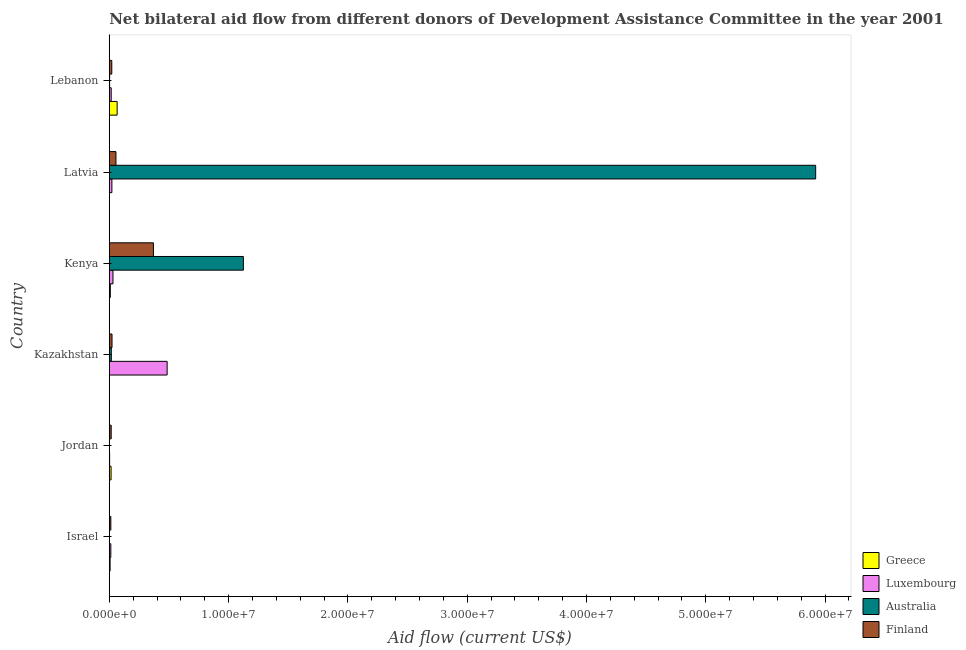Are the number of bars per tick equal to the number of legend labels?
Ensure brevity in your answer.  Yes. What is the label of the 4th group of bars from the top?
Offer a very short reply. Kazakhstan. In how many cases, is the number of bars for a given country not equal to the number of legend labels?
Ensure brevity in your answer.  0. What is the amount of aid given by australia in Kazakhstan?
Provide a succinct answer. 1.70e+05. Across all countries, what is the maximum amount of aid given by australia?
Keep it short and to the point. 5.92e+07. Across all countries, what is the minimum amount of aid given by luxembourg?
Offer a terse response. 3.00e+04. In which country was the amount of aid given by greece maximum?
Ensure brevity in your answer.  Lebanon. In which country was the amount of aid given by greece minimum?
Your answer should be compact. Kazakhstan. What is the total amount of aid given by finland in the graph?
Provide a succinct answer. 4.99e+06. What is the difference between the amount of aid given by greece in Israel and that in Lebanon?
Give a very brief answer. -5.90e+05. What is the difference between the amount of aid given by finland in Latvia and the amount of aid given by australia in Israel?
Keep it short and to the point. 5.50e+05. What is the average amount of aid given by finland per country?
Provide a succinct answer. 8.32e+05. What is the difference between the amount of aid given by luxembourg and amount of aid given by australia in Kenya?
Provide a succinct answer. -1.09e+07. In how many countries, is the amount of aid given by luxembourg greater than 36000000 US$?
Make the answer very short. 0. What is the ratio of the amount of aid given by greece in Kenya to that in Lebanon?
Provide a succinct answer. 0.14. Is the amount of aid given by finland in Jordan less than that in Kazakhstan?
Ensure brevity in your answer.  Yes. Is the difference between the amount of aid given by greece in Jordan and Kazakhstan greater than the difference between the amount of aid given by luxembourg in Jordan and Kazakhstan?
Keep it short and to the point. Yes. What is the difference between the highest and the second highest amount of aid given by greece?
Your answer should be compact. 5.10e+05. What is the difference between the highest and the lowest amount of aid given by australia?
Keep it short and to the point. 5.92e+07. In how many countries, is the amount of aid given by greece greater than the average amount of aid given by greece taken over all countries?
Provide a short and direct response. 1. Is it the case that in every country, the sum of the amount of aid given by luxembourg and amount of aid given by finland is greater than the sum of amount of aid given by greece and amount of aid given by australia?
Keep it short and to the point. No. What does the 2nd bar from the top in Israel represents?
Make the answer very short. Australia. What does the 4th bar from the bottom in Kenya represents?
Offer a terse response. Finland. Is it the case that in every country, the sum of the amount of aid given by greece and amount of aid given by luxembourg is greater than the amount of aid given by australia?
Offer a terse response. No. How many bars are there?
Offer a terse response. 24. Are all the bars in the graph horizontal?
Provide a succinct answer. Yes. How many countries are there in the graph?
Ensure brevity in your answer.  6. What is the difference between two consecutive major ticks on the X-axis?
Your answer should be compact. 1.00e+07. Are the values on the major ticks of X-axis written in scientific E-notation?
Provide a succinct answer. Yes. Does the graph contain grids?
Keep it short and to the point. No. Where does the legend appear in the graph?
Provide a short and direct response. Bottom right. How are the legend labels stacked?
Offer a terse response. Vertical. What is the title of the graph?
Provide a succinct answer. Net bilateral aid flow from different donors of Development Assistance Committee in the year 2001. Does "Agricultural land" appear as one of the legend labels in the graph?
Your answer should be very brief. No. What is the label or title of the Y-axis?
Your answer should be very brief. Country. What is the Aid flow (current US$) in Finland in Israel?
Your answer should be very brief. 1.30e+05. What is the Aid flow (current US$) of Greece in Jordan?
Keep it short and to the point. 1.50e+05. What is the Aid flow (current US$) of Luxembourg in Kazakhstan?
Your answer should be compact. 4.85e+06. What is the Aid flow (current US$) of Finland in Kazakhstan?
Give a very brief answer. 2.30e+05. What is the Aid flow (current US$) of Greece in Kenya?
Your answer should be compact. 9.00e+04. What is the Aid flow (current US$) in Australia in Kenya?
Keep it short and to the point. 1.12e+07. What is the Aid flow (current US$) of Finland in Kenya?
Offer a very short reply. 3.70e+06. What is the Aid flow (current US$) in Greece in Latvia?
Provide a short and direct response. 2.00e+04. What is the Aid flow (current US$) in Luxembourg in Latvia?
Offer a terse response. 2.20e+05. What is the Aid flow (current US$) in Australia in Latvia?
Offer a terse response. 5.92e+07. What is the Aid flow (current US$) in Finland in Latvia?
Offer a terse response. 5.60e+05. What is the Aid flow (current US$) in Greece in Lebanon?
Provide a succinct answer. 6.60e+05. What is the Aid flow (current US$) in Luxembourg in Lebanon?
Keep it short and to the point. 1.60e+05. Across all countries, what is the maximum Aid flow (current US$) in Luxembourg?
Provide a short and direct response. 4.85e+06. Across all countries, what is the maximum Aid flow (current US$) of Australia?
Keep it short and to the point. 5.92e+07. Across all countries, what is the maximum Aid flow (current US$) of Finland?
Your response must be concise. 3.70e+06. Across all countries, what is the minimum Aid flow (current US$) of Finland?
Ensure brevity in your answer.  1.30e+05. What is the total Aid flow (current US$) of Greece in the graph?
Make the answer very short. 1.00e+06. What is the total Aid flow (current US$) in Luxembourg in the graph?
Provide a succinct answer. 5.70e+06. What is the total Aid flow (current US$) of Australia in the graph?
Keep it short and to the point. 7.07e+07. What is the total Aid flow (current US$) in Finland in the graph?
Provide a short and direct response. 4.99e+06. What is the difference between the Aid flow (current US$) in Greece in Israel and that in Jordan?
Make the answer very short. -8.00e+04. What is the difference between the Aid flow (current US$) of Luxembourg in Israel and that in Jordan?
Offer a terse response. 1.00e+05. What is the difference between the Aid flow (current US$) in Greece in Israel and that in Kazakhstan?
Offer a very short reply. 6.00e+04. What is the difference between the Aid flow (current US$) in Luxembourg in Israel and that in Kazakhstan?
Give a very brief answer. -4.72e+06. What is the difference between the Aid flow (current US$) of Australia in Israel and that in Kazakhstan?
Your response must be concise. -1.60e+05. What is the difference between the Aid flow (current US$) of Finland in Israel and that in Kazakhstan?
Make the answer very short. -1.00e+05. What is the difference between the Aid flow (current US$) of Luxembourg in Israel and that in Kenya?
Give a very brief answer. -1.80e+05. What is the difference between the Aid flow (current US$) in Australia in Israel and that in Kenya?
Provide a short and direct response. -1.12e+07. What is the difference between the Aid flow (current US$) in Finland in Israel and that in Kenya?
Your response must be concise. -3.57e+06. What is the difference between the Aid flow (current US$) in Luxembourg in Israel and that in Latvia?
Your answer should be compact. -9.00e+04. What is the difference between the Aid flow (current US$) of Australia in Israel and that in Latvia?
Your answer should be compact. -5.92e+07. What is the difference between the Aid flow (current US$) in Finland in Israel and that in Latvia?
Provide a succinct answer. -4.30e+05. What is the difference between the Aid flow (current US$) of Greece in Israel and that in Lebanon?
Provide a succinct answer. -5.90e+05. What is the difference between the Aid flow (current US$) of Luxembourg in Israel and that in Lebanon?
Provide a short and direct response. -3.00e+04. What is the difference between the Aid flow (current US$) in Luxembourg in Jordan and that in Kazakhstan?
Give a very brief answer. -4.82e+06. What is the difference between the Aid flow (current US$) in Australia in Jordan and that in Kazakhstan?
Provide a succinct answer. -1.60e+05. What is the difference between the Aid flow (current US$) in Greece in Jordan and that in Kenya?
Provide a succinct answer. 6.00e+04. What is the difference between the Aid flow (current US$) of Luxembourg in Jordan and that in Kenya?
Provide a succinct answer. -2.80e+05. What is the difference between the Aid flow (current US$) in Australia in Jordan and that in Kenya?
Provide a short and direct response. -1.12e+07. What is the difference between the Aid flow (current US$) in Finland in Jordan and that in Kenya?
Make the answer very short. -3.54e+06. What is the difference between the Aid flow (current US$) in Luxembourg in Jordan and that in Latvia?
Keep it short and to the point. -1.90e+05. What is the difference between the Aid flow (current US$) in Australia in Jordan and that in Latvia?
Your answer should be compact. -5.92e+07. What is the difference between the Aid flow (current US$) in Finland in Jordan and that in Latvia?
Give a very brief answer. -4.00e+05. What is the difference between the Aid flow (current US$) in Greece in Jordan and that in Lebanon?
Ensure brevity in your answer.  -5.10e+05. What is the difference between the Aid flow (current US$) of Greece in Kazakhstan and that in Kenya?
Give a very brief answer. -8.00e+04. What is the difference between the Aid flow (current US$) of Luxembourg in Kazakhstan and that in Kenya?
Offer a very short reply. 4.54e+06. What is the difference between the Aid flow (current US$) of Australia in Kazakhstan and that in Kenya?
Keep it short and to the point. -1.11e+07. What is the difference between the Aid flow (current US$) in Finland in Kazakhstan and that in Kenya?
Make the answer very short. -3.47e+06. What is the difference between the Aid flow (current US$) in Luxembourg in Kazakhstan and that in Latvia?
Provide a short and direct response. 4.63e+06. What is the difference between the Aid flow (current US$) of Australia in Kazakhstan and that in Latvia?
Give a very brief answer. -5.90e+07. What is the difference between the Aid flow (current US$) of Finland in Kazakhstan and that in Latvia?
Your response must be concise. -3.30e+05. What is the difference between the Aid flow (current US$) of Greece in Kazakhstan and that in Lebanon?
Offer a very short reply. -6.50e+05. What is the difference between the Aid flow (current US$) of Luxembourg in Kazakhstan and that in Lebanon?
Keep it short and to the point. 4.69e+06. What is the difference between the Aid flow (current US$) in Luxembourg in Kenya and that in Latvia?
Offer a terse response. 9.00e+04. What is the difference between the Aid flow (current US$) in Australia in Kenya and that in Latvia?
Your answer should be very brief. -4.80e+07. What is the difference between the Aid flow (current US$) in Finland in Kenya and that in Latvia?
Provide a short and direct response. 3.14e+06. What is the difference between the Aid flow (current US$) in Greece in Kenya and that in Lebanon?
Provide a short and direct response. -5.70e+05. What is the difference between the Aid flow (current US$) of Australia in Kenya and that in Lebanon?
Provide a succinct answer. 1.12e+07. What is the difference between the Aid flow (current US$) in Finland in Kenya and that in Lebanon?
Offer a very short reply. 3.49e+06. What is the difference between the Aid flow (current US$) of Greece in Latvia and that in Lebanon?
Provide a succinct answer. -6.40e+05. What is the difference between the Aid flow (current US$) of Luxembourg in Latvia and that in Lebanon?
Make the answer very short. 6.00e+04. What is the difference between the Aid flow (current US$) of Australia in Latvia and that in Lebanon?
Provide a succinct answer. 5.92e+07. What is the difference between the Aid flow (current US$) of Finland in Latvia and that in Lebanon?
Offer a terse response. 3.50e+05. What is the difference between the Aid flow (current US$) in Luxembourg in Israel and the Aid flow (current US$) in Australia in Jordan?
Keep it short and to the point. 1.20e+05. What is the difference between the Aid flow (current US$) of Australia in Israel and the Aid flow (current US$) of Finland in Jordan?
Make the answer very short. -1.50e+05. What is the difference between the Aid flow (current US$) of Greece in Israel and the Aid flow (current US$) of Luxembourg in Kazakhstan?
Your answer should be compact. -4.78e+06. What is the difference between the Aid flow (current US$) in Greece in Israel and the Aid flow (current US$) in Finland in Kazakhstan?
Your answer should be compact. -1.60e+05. What is the difference between the Aid flow (current US$) in Luxembourg in Israel and the Aid flow (current US$) in Finland in Kazakhstan?
Provide a short and direct response. -1.00e+05. What is the difference between the Aid flow (current US$) in Greece in Israel and the Aid flow (current US$) in Australia in Kenya?
Keep it short and to the point. -1.12e+07. What is the difference between the Aid flow (current US$) in Greece in Israel and the Aid flow (current US$) in Finland in Kenya?
Your answer should be compact. -3.63e+06. What is the difference between the Aid flow (current US$) of Luxembourg in Israel and the Aid flow (current US$) of Australia in Kenya?
Your answer should be very brief. -1.11e+07. What is the difference between the Aid flow (current US$) in Luxembourg in Israel and the Aid flow (current US$) in Finland in Kenya?
Your answer should be compact. -3.57e+06. What is the difference between the Aid flow (current US$) of Australia in Israel and the Aid flow (current US$) of Finland in Kenya?
Make the answer very short. -3.69e+06. What is the difference between the Aid flow (current US$) in Greece in Israel and the Aid flow (current US$) in Luxembourg in Latvia?
Provide a short and direct response. -1.50e+05. What is the difference between the Aid flow (current US$) in Greece in Israel and the Aid flow (current US$) in Australia in Latvia?
Offer a very short reply. -5.91e+07. What is the difference between the Aid flow (current US$) in Greece in Israel and the Aid flow (current US$) in Finland in Latvia?
Your answer should be very brief. -4.90e+05. What is the difference between the Aid flow (current US$) in Luxembourg in Israel and the Aid flow (current US$) in Australia in Latvia?
Your response must be concise. -5.91e+07. What is the difference between the Aid flow (current US$) of Luxembourg in Israel and the Aid flow (current US$) of Finland in Latvia?
Offer a very short reply. -4.30e+05. What is the difference between the Aid flow (current US$) in Australia in Israel and the Aid flow (current US$) in Finland in Latvia?
Your response must be concise. -5.50e+05. What is the difference between the Aid flow (current US$) of Greece in Israel and the Aid flow (current US$) of Luxembourg in Lebanon?
Your answer should be very brief. -9.00e+04. What is the difference between the Aid flow (current US$) in Greece in Israel and the Aid flow (current US$) in Finland in Lebanon?
Keep it short and to the point. -1.40e+05. What is the difference between the Aid flow (current US$) of Luxembourg in Israel and the Aid flow (current US$) of Australia in Lebanon?
Offer a very short reply. 1.00e+05. What is the difference between the Aid flow (current US$) in Luxembourg in Israel and the Aid flow (current US$) in Finland in Lebanon?
Give a very brief answer. -8.00e+04. What is the difference between the Aid flow (current US$) in Greece in Jordan and the Aid flow (current US$) in Luxembourg in Kazakhstan?
Provide a short and direct response. -4.70e+06. What is the difference between the Aid flow (current US$) in Luxembourg in Jordan and the Aid flow (current US$) in Finland in Kazakhstan?
Your answer should be compact. -2.00e+05. What is the difference between the Aid flow (current US$) of Greece in Jordan and the Aid flow (current US$) of Luxembourg in Kenya?
Your response must be concise. -1.60e+05. What is the difference between the Aid flow (current US$) of Greece in Jordan and the Aid flow (current US$) of Australia in Kenya?
Your answer should be very brief. -1.11e+07. What is the difference between the Aid flow (current US$) of Greece in Jordan and the Aid flow (current US$) of Finland in Kenya?
Give a very brief answer. -3.55e+06. What is the difference between the Aid flow (current US$) in Luxembourg in Jordan and the Aid flow (current US$) in Australia in Kenya?
Give a very brief answer. -1.12e+07. What is the difference between the Aid flow (current US$) in Luxembourg in Jordan and the Aid flow (current US$) in Finland in Kenya?
Make the answer very short. -3.67e+06. What is the difference between the Aid flow (current US$) in Australia in Jordan and the Aid flow (current US$) in Finland in Kenya?
Your answer should be compact. -3.69e+06. What is the difference between the Aid flow (current US$) in Greece in Jordan and the Aid flow (current US$) in Luxembourg in Latvia?
Give a very brief answer. -7.00e+04. What is the difference between the Aid flow (current US$) of Greece in Jordan and the Aid flow (current US$) of Australia in Latvia?
Your response must be concise. -5.91e+07. What is the difference between the Aid flow (current US$) in Greece in Jordan and the Aid flow (current US$) in Finland in Latvia?
Your response must be concise. -4.10e+05. What is the difference between the Aid flow (current US$) in Luxembourg in Jordan and the Aid flow (current US$) in Australia in Latvia?
Your response must be concise. -5.92e+07. What is the difference between the Aid flow (current US$) of Luxembourg in Jordan and the Aid flow (current US$) of Finland in Latvia?
Your answer should be compact. -5.30e+05. What is the difference between the Aid flow (current US$) in Australia in Jordan and the Aid flow (current US$) in Finland in Latvia?
Offer a very short reply. -5.50e+05. What is the difference between the Aid flow (current US$) of Greece in Jordan and the Aid flow (current US$) of Australia in Lebanon?
Your answer should be very brief. 1.20e+05. What is the difference between the Aid flow (current US$) of Greece in Jordan and the Aid flow (current US$) of Finland in Lebanon?
Your answer should be compact. -6.00e+04. What is the difference between the Aid flow (current US$) of Luxembourg in Jordan and the Aid flow (current US$) of Australia in Lebanon?
Make the answer very short. 0. What is the difference between the Aid flow (current US$) of Australia in Jordan and the Aid flow (current US$) of Finland in Lebanon?
Your answer should be very brief. -2.00e+05. What is the difference between the Aid flow (current US$) of Greece in Kazakhstan and the Aid flow (current US$) of Luxembourg in Kenya?
Give a very brief answer. -3.00e+05. What is the difference between the Aid flow (current US$) of Greece in Kazakhstan and the Aid flow (current US$) of Australia in Kenya?
Ensure brevity in your answer.  -1.12e+07. What is the difference between the Aid flow (current US$) of Greece in Kazakhstan and the Aid flow (current US$) of Finland in Kenya?
Provide a short and direct response. -3.69e+06. What is the difference between the Aid flow (current US$) in Luxembourg in Kazakhstan and the Aid flow (current US$) in Australia in Kenya?
Ensure brevity in your answer.  -6.39e+06. What is the difference between the Aid flow (current US$) in Luxembourg in Kazakhstan and the Aid flow (current US$) in Finland in Kenya?
Offer a terse response. 1.15e+06. What is the difference between the Aid flow (current US$) of Australia in Kazakhstan and the Aid flow (current US$) of Finland in Kenya?
Provide a short and direct response. -3.53e+06. What is the difference between the Aid flow (current US$) in Greece in Kazakhstan and the Aid flow (current US$) in Australia in Latvia?
Provide a short and direct response. -5.92e+07. What is the difference between the Aid flow (current US$) in Greece in Kazakhstan and the Aid flow (current US$) in Finland in Latvia?
Keep it short and to the point. -5.50e+05. What is the difference between the Aid flow (current US$) in Luxembourg in Kazakhstan and the Aid flow (current US$) in Australia in Latvia?
Provide a succinct answer. -5.44e+07. What is the difference between the Aid flow (current US$) in Luxembourg in Kazakhstan and the Aid flow (current US$) in Finland in Latvia?
Provide a short and direct response. 4.29e+06. What is the difference between the Aid flow (current US$) in Australia in Kazakhstan and the Aid flow (current US$) in Finland in Latvia?
Make the answer very short. -3.90e+05. What is the difference between the Aid flow (current US$) in Greece in Kazakhstan and the Aid flow (current US$) in Luxembourg in Lebanon?
Provide a short and direct response. -1.50e+05. What is the difference between the Aid flow (current US$) of Greece in Kazakhstan and the Aid flow (current US$) of Australia in Lebanon?
Offer a terse response. -2.00e+04. What is the difference between the Aid flow (current US$) in Luxembourg in Kazakhstan and the Aid flow (current US$) in Australia in Lebanon?
Ensure brevity in your answer.  4.82e+06. What is the difference between the Aid flow (current US$) in Luxembourg in Kazakhstan and the Aid flow (current US$) in Finland in Lebanon?
Provide a short and direct response. 4.64e+06. What is the difference between the Aid flow (current US$) of Australia in Kazakhstan and the Aid flow (current US$) of Finland in Lebanon?
Provide a succinct answer. -4.00e+04. What is the difference between the Aid flow (current US$) of Greece in Kenya and the Aid flow (current US$) of Luxembourg in Latvia?
Make the answer very short. -1.30e+05. What is the difference between the Aid flow (current US$) of Greece in Kenya and the Aid flow (current US$) of Australia in Latvia?
Your answer should be very brief. -5.91e+07. What is the difference between the Aid flow (current US$) of Greece in Kenya and the Aid flow (current US$) of Finland in Latvia?
Your answer should be compact. -4.70e+05. What is the difference between the Aid flow (current US$) in Luxembourg in Kenya and the Aid flow (current US$) in Australia in Latvia?
Your answer should be compact. -5.89e+07. What is the difference between the Aid flow (current US$) in Australia in Kenya and the Aid flow (current US$) in Finland in Latvia?
Provide a short and direct response. 1.07e+07. What is the difference between the Aid flow (current US$) in Greece in Kenya and the Aid flow (current US$) in Finland in Lebanon?
Give a very brief answer. -1.20e+05. What is the difference between the Aid flow (current US$) of Luxembourg in Kenya and the Aid flow (current US$) of Finland in Lebanon?
Offer a very short reply. 1.00e+05. What is the difference between the Aid flow (current US$) of Australia in Kenya and the Aid flow (current US$) of Finland in Lebanon?
Offer a very short reply. 1.10e+07. What is the difference between the Aid flow (current US$) in Greece in Latvia and the Aid flow (current US$) in Australia in Lebanon?
Offer a very short reply. -10000. What is the difference between the Aid flow (current US$) in Greece in Latvia and the Aid flow (current US$) in Finland in Lebanon?
Offer a terse response. -1.90e+05. What is the difference between the Aid flow (current US$) in Luxembourg in Latvia and the Aid flow (current US$) in Australia in Lebanon?
Give a very brief answer. 1.90e+05. What is the difference between the Aid flow (current US$) in Australia in Latvia and the Aid flow (current US$) in Finland in Lebanon?
Your answer should be very brief. 5.90e+07. What is the average Aid flow (current US$) in Greece per country?
Your response must be concise. 1.67e+05. What is the average Aid flow (current US$) of Luxembourg per country?
Ensure brevity in your answer.  9.50e+05. What is the average Aid flow (current US$) in Australia per country?
Provide a short and direct response. 1.18e+07. What is the average Aid flow (current US$) in Finland per country?
Your answer should be compact. 8.32e+05. What is the difference between the Aid flow (current US$) of Greece and Aid flow (current US$) of Luxembourg in Israel?
Your response must be concise. -6.00e+04. What is the difference between the Aid flow (current US$) of Australia and Aid flow (current US$) of Finland in Israel?
Offer a terse response. -1.20e+05. What is the difference between the Aid flow (current US$) of Greece and Aid flow (current US$) of Luxembourg in Kazakhstan?
Ensure brevity in your answer.  -4.84e+06. What is the difference between the Aid flow (current US$) of Greece and Aid flow (current US$) of Finland in Kazakhstan?
Keep it short and to the point. -2.20e+05. What is the difference between the Aid flow (current US$) of Luxembourg and Aid flow (current US$) of Australia in Kazakhstan?
Your answer should be compact. 4.68e+06. What is the difference between the Aid flow (current US$) of Luxembourg and Aid flow (current US$) of Finland in Kazakhstan?
Make the answer very short. 4.62e+06. What is the difference between the Aid flow (current US$) of Australia and Aid flow (current US$) of Finland in Kazakhstan?
Make the answer very short. -6.00e+04. What is the difference between the Aid flow (current US$) of Greece and Aid flow (current US$) of Luxembourg in Kenya?
Your answer should be very brief. -2.20e+05. What is the difference between the Aid flow (current US$) in Greece and Aid flow (current US$) in Australia in Kenya?
Offer a very short reply. -1.12e+07. What is the difference between the Aid flow (current US$) in Greece and Aid flow (current US$) in Finland in Kenya?
Your answer should be compact. -3.61e+06. What is the difference between the Aid flow (current US$) in Luxembourg and Aid flow (current US$) in Australia in Kenya?
Provide a succinct answer. -1.09e+07. What is the difference between the Aid flow (current US$) in Luxembourg and Aid flow (current US$) in Finland in Kenya?
Keep it short and to the point. -3.39e+06. What is the difference between the Aid flow (current US$) in Australia and Aid flow (current US$) in Finland in Kenya?
Keep it short and to the point. 7.54e+06. What is the difference between the Aid flow (current US$) of Greece and Aid flow (current US$) of Australia in Latvia?
Your answer should be very brief. -5.92e+07. What is the difference between the Aid flow (current US$) of Greece and Aid flow (current US$) of Finland in Latvia?
Offer a terse response. -5.40e+05. What is the difference between the Aid flow (current US$) in Luxembourg and Aid flow (current US$) in Australia in Latvia?
Ensure brevity in your answer.  -5.90e+07. What is the difference between the Aid flow (current US$) of Luxembourg and Aid flow (current US$) of Finland in Latvia?
Give a very brief answer. -3.40e+05. What is the difference between the Aid flow (current US$) in Australia and Aid flow (current US$) in Finland in Latvia?
Give a very brief answer. 5.86e+07. What is the difference between the Aid flow (current US$) of Greece and Aid flow (current US$) of Australia in Lebanon?
Your answer should be compact. 6.30e+05. What is the difference between the Aid flow (current US$) in Greece and Aid flow (current US$) in Finland in Lebanon?
Provide a succinct answer. 4.50e+05. What is the difference between the Aid flow (current US$) of Luxembourg and Aid flow (current US$) of Finland in Lebanon?
Offer a terse response. -5.00e+04. What is the ratio of the Aid flow (current US$) of Greece in Israel to that in Jordan?
Make the answer very short. 0.47. What is the ratio of the Aid flow (current US$) of Luxembourg in Israel to that in Jordan?
Ensure brevity in your answer.  4.33. What is the ratio of the Aid flow (current US$) in Finland in Israel to that in Jordan?
Provide a succinct answer. 0.81. What is the ratio of the Aid flow (current US$) in Greece in Israel to that in Kazakhstan?
Keep it short and to the point. 7. What is the ratio of the Aid flow (current US$) in Luxembourg in Israel to that in Kazakhstan?
Ensure brevity in your answer.  0.03. What is the ratio of the Aid flow (current US$) of Australia in Israel to that in Kazakhstan?
Your response must be concise. 0.06. What is the ratio of the Aid flow (current US$) of Finland in Israel to that in Kazakhstan?
Ensure brevity in your answer.  0.57. What is the ratio of the Aid flow (current US$) in Luxembourg in Israel to that in Kenya?
Provide a short and direct response. 0.42. What is the ratio of the Aid flow (current US$) in Australia in Israel to that in Kenya?
Give a very brief answer. 0. What is the ratio of the Aid flow (current US$) in Finland in Israel to that in Kenya?
Give a very brief answer. 0.04. What is the ratio of the Aid flow (current US$) in Greece in Israel to that in Latvia?
Give a very brief answer. 3.5. What is the ratio of the Aid flow (current US$) in Luxembourg in Israel to that in Latvia?
Give a very brief answer. 0.59. What is the ratio of the Aid flow (current US$) in Australia in Israel to that in Latvia?
Your answer should be compact. 0. What is the ratio of the Aid flow (current US$) of Finland in Israel to that in Latvia?
Ensure brevity in your answer.  0.23. What is the ratio of the Aid flow (current US$) of Greece in Israel to that in Lebanon?
Offer a very short reply. 0.11. What is the ratio of the Aid flow (current US$) in Luxembourg in Israel to that in Lebanon?
Offer a terse response. 0.81. What is the ratio of the Aid flow (current US$) in Australia in Israel to that in Lebanon?
Your answer should be compact. 0.33. What is the ratio of the Aid flow (current US$) of Finland in Israel to that in Lebanon?
Your response must be concise. 0.62. What is the ratio of the Aid flow (current US$) in Luxembourg in Jordan to that in Kazakhstan?
Your answer should be compact. 0.01. What is the ratio of the Aid flow (current US$) of Australia in Jordan to that in Kazakhstan?
Your response must be concise. 0.06. What is the ratio of the Aid flow (current US$) of Finland in Jordan to that in Kazakhstan?
Your answer should be compact. 0.7. What is the ratio of the Aid flow (current US$) of Greece in Jordan to that in Kenya?
Keep it short and to the point. 1.67. What is the ratio of the Aid flow (current US$) in Luxembourg in Jordan to that in Kenya?
Make the answer very short. 0.1. What is the ratio of the Aid flow (current US$) of Australia in Jordan to that in Kenya?
Your answer should be very brief. 0. What is the ratio of the Aid flow (current US$) in Finland in Jordan to that in Kenya?
Make the answer very short. 0.04. What is the ratio of the Aid flow (current US$) in Greece in Jordan to that in Latvia?
Make the answer very short. 7.5. What is the ratio of the Aid flow (current US$) of Luxembourg in Jordan to that in Latvia?
Keep it short and to the point. 0.14. What is the ratio of the Aid flow (current US$) in Finland in Jordan to that in Latvia?
Provide a succinct answer. 0.29. What is the ratio of the Aid flow (current US$) in Greece in Jordan to that in Lebanon?
Your answer should be very brief. 0.23. What is the ratio of the Aid flow (current US$) of Luxembourg in Jordan to that in Lebanon?
Offer a terse response. 0.19. What is the ratio of the Aid flow (current US$) in Finland in Jordan to that in Lebanon?
Ensure brevity in your answer.  0.76. What is the ratio of the Aid flow (current US$) of Luxembourg in Kazakhstan to that in Kenya?
Your response must be concise. 15.65. What is the ratio of the Aid flow (current US$) in Australia in Kazakhstan to that in Kenya?
Provide a succinct answer. 0.02. What is the ratio of the Aid flow (current US$) in Finland in Kazakhstan to that in Kenya?
Offer a terse response. 0.06. What is the ratio of the Aid flow (current US$) of Luxembourg in Kazakhstan to that in Latvia?
Offer a very short reply. 22.05. What is the ratio of the Aid flow (current US$) in Australia in Kazakhstan to that in Latvia?
Offer a terse response. 0. What is the ratio of the Aid flow (current US$) of Finland in Kazakhstan to that in Latvia?
Offer a terse response. 0.41. What is the ratio of the Aid flow (current US$) of Greece in Kazakhstan to that in Lebanon?
Your answer should be compact. 0.02. What is the ratio of the Aid flow (current US$) of Luxembourg in Kazakhstan to that in Lebanon?
Ensure brevity in your answer.  30.31. What is the ratio of the Aid flow (current US$) of Australia in Kazakhstan to that in Lebanon?
Offer a very short reply. 5.67. What is the ratio of the Aid flow (current US$) in Finland in Kazakhstan to that in Lebanon?
Your response must be concise. 1.1. What is the ratio of the Aid flow (current US$) in Greece in Kenya to that in Latvia?
Provide a succinct answer. 4.5. What is the ratio of the Aid flow (current US$) of Luxembourg in Kenya to that in Latvia?
Your response must be concise. 1.41. What is the ratio of the Aid flow (current US$) of Australia in Kenya to that in Latvia?
Provide a short and direct response. 0.19. What is the ratio of the Aid flow (current US$) in Finland in Kenya to that in Latvia?
Your response must be concise. 6.61. What is the ratio of the Aid flow (current US$) of Greece in Kenya to that in Lebanon?
Your answer should be very brief. 0.14. What is the ratio of the Aid flow (current US$) in Luxembourg in Kenya to that in Lebanon?
Provide a short and direct response. 1.94. What is the ratio of the Aid flow (current US$) of Australia in Kenya to that in Lebanon?
Provide a short and direct response. 374.67. What is the ratio of the Aid flow (current US$) in Finland in Kenya to that in Lebanon?
Your answer should be compact. 17.62. What is the ratio of the Aid flow (current US$) of Greece in Latvia to that in Lebanon?
Offer a terse response. 0.03. What is the ratio of the Aid flow (current US$) of Luxembourg in Latvia to that in Lebanon?
Provide a succinct answer. 1.38. What is the ratio of the Aid flow (current US$) in Australia in Latvia to that in Lebanon?
Provide a short and direct response. 1973.67. What is the ratio of the Aid flow (current US$) of Finland in Latvia to that in Lebanon?
Offer a very short reply. 2.67. What is the difference between the highest and the second highest Aid flow (current US$) of Greece?
Provide a succinct answer. 5.10e+05. What is the difference between the highest and the second highest Aid flow (current US$) in Luxembourg?
Your answer should be compact. 4.54e+06. What is the difference between the highest and the second highest Aid flow (current US$) of Australia?
Provide a short and direct response. 4.80e+07. What is the difference between the highest and the second highest Aid flow (current US$) of Finland?
Your response must be concise. 3.14e+06. What is the difference between the highest and the lowest Aid flow (current US$) of Greece?
Offer a terse response. 6.50e+05. What is the difference between the highest and the lowest Aid flow (current US$) in Luxembourg?
Ensure brevity in your answer.  4.82e+06. What is the difference between the highest and the lowest Aid flow (current US$) in Australia?
Your answer should be compact. 5.92e+07. What is the difference between the highest and the lowest Aid flow (current US$) in Finland?
Offer a terse response. 3.57e+06. 